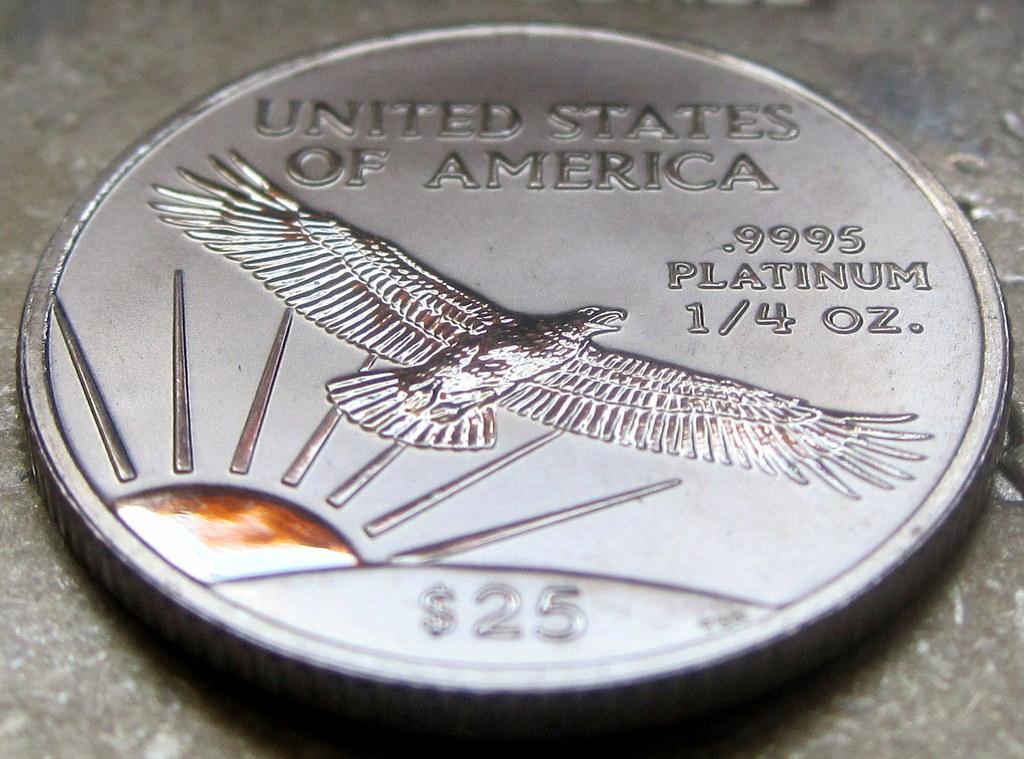Where is this coin produced?
Offer a terse response. United states of america. What is the weight of this coin?
Give a very brief answer. 1/4 oz. 